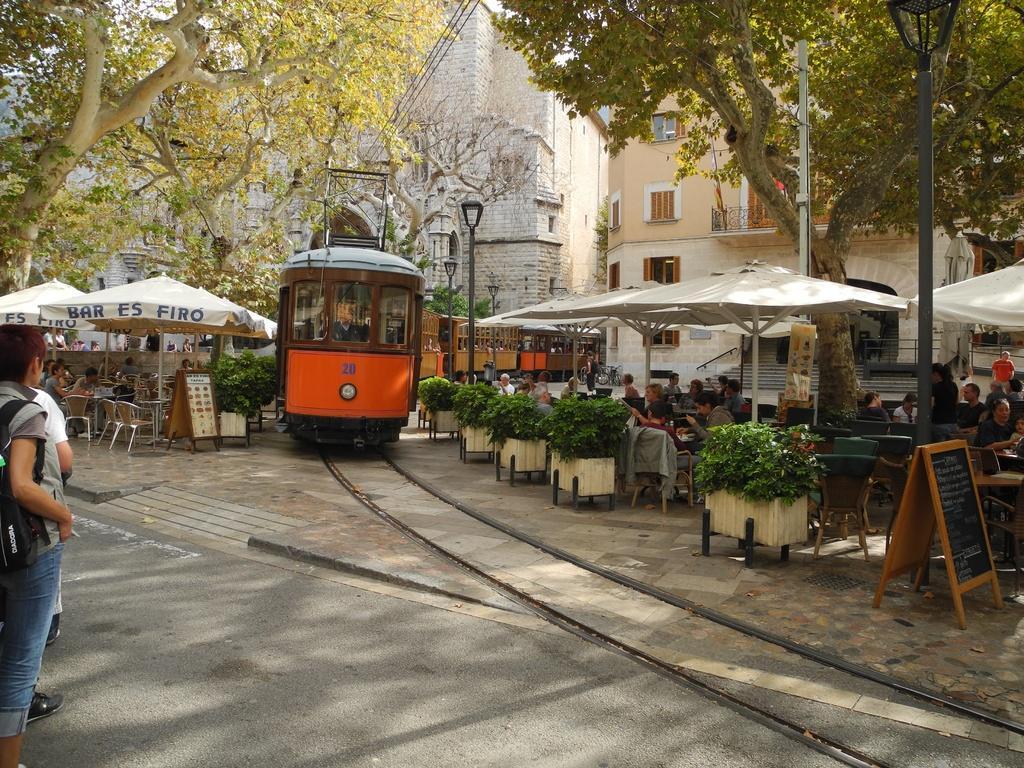Please provide a concise description of this image. This picture is clicked outside. In the center there is a train seems to be running on the railway track and we can see the chairs, tables are placed under the tents and we can see the group of persons sitting on the chairs under the tents. On the left there are some persons and we can see there are many number of objects placed on the ground. In the background we can see the buildings, trees and the lamps attached to the poles. 